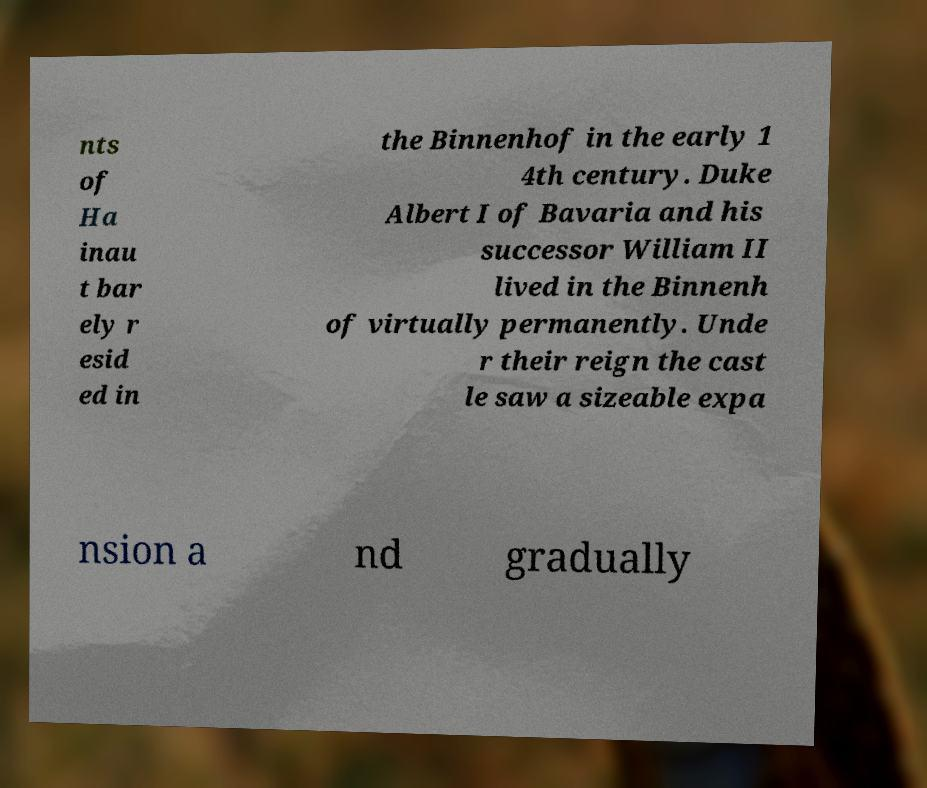I need the written content from this picture converted into text. Can you do that? nts of Ha inau t bar ely r esid ed in the Binnenhof in the early 1 4th century. Duke Albert I of Bavaria and his successor William II lived in the Binnenh of virtually permanently. Unde r their reign the cast le saw a sizeable expa nsion a nd gradually 